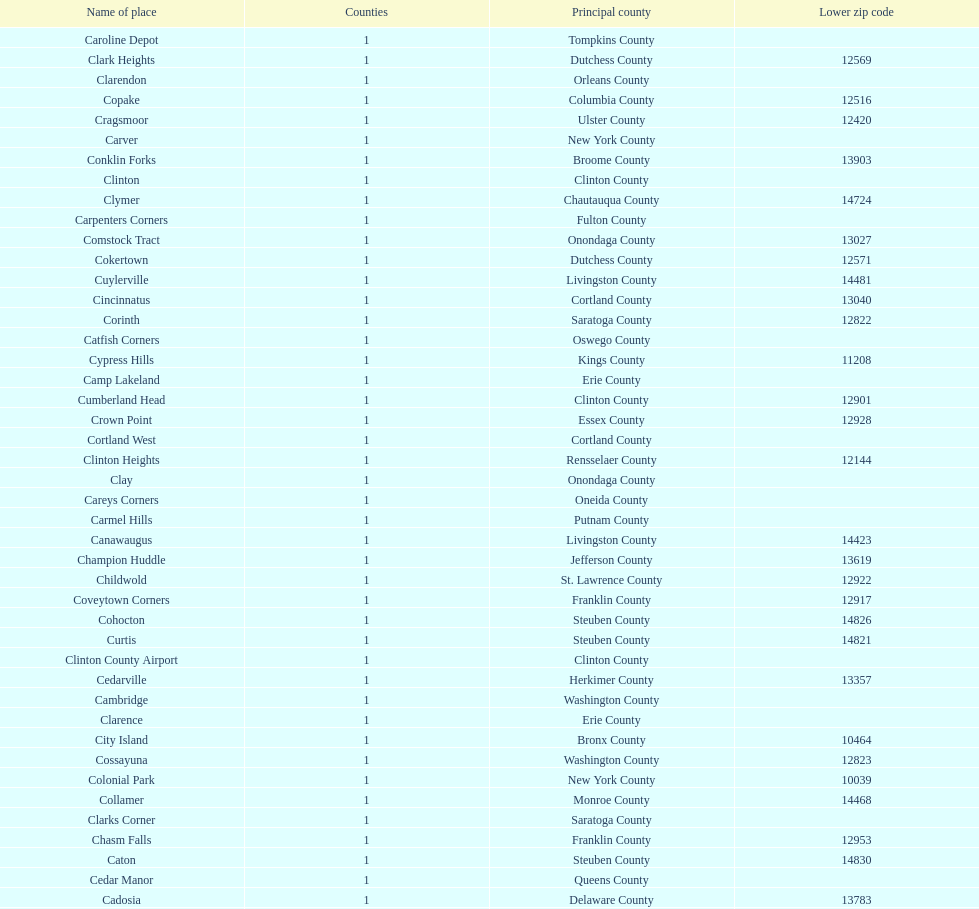How many places are in greene county? 10. 